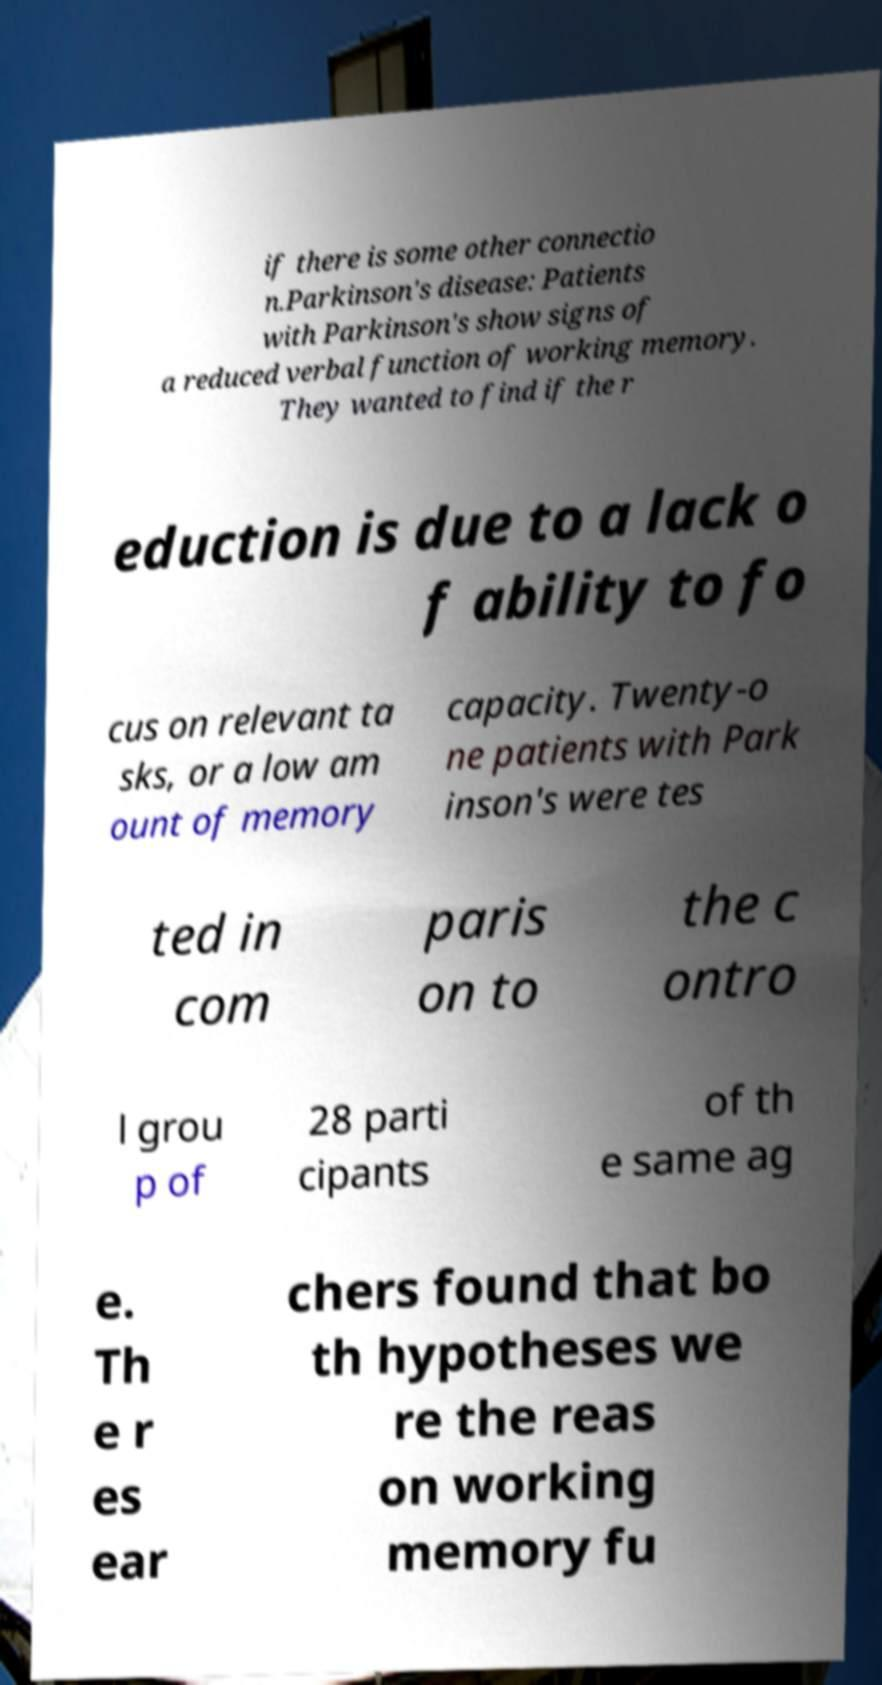For documentation purposes, I need the text within this image transcribed. Could you provide that? if there is some other connectio n.Parkinson's disease: Patients with Parkinson's show signs of a reduced verbal function of working memory. They wanted to find if the r eduction is due to a lack o f ability to fo cus on relevant ta sks, or a low am ount of memory capacity. Twenty-o ne patients with Park inson's were tes ted in com paris on to the c ontro l grou p of 28 parti cipants of th e same ag e. Th e r es ear chers found that bo th hypotheses we re the reas on working memory fu 